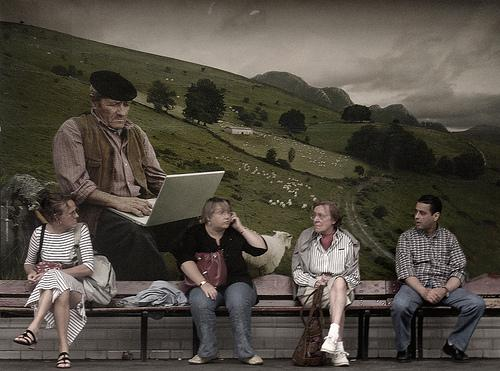Question: where are the people sitting?
Choices:
A. On the beach.
B. On the rocks.
C. On a bench.
D. On the curb.
Answer with the letter. Answer: C Question: who is on the bench?
Choices:
A. Four people.
B. One person.
C. No one.
D. Two girls.
Answer with the letter. Answer: A Question: what is on the mural?
Choices:
A. A football player.
B. A soldier.
C. A man with a computer.
D. An airman.
Answer with the letter. Answer: C Question: what does the woman have by her ear?
Choices:
A. An earring.
B. A hat.
C. Headphones.
D. A phone.
Answer with the letter. Answer: D Question: why does the woman have a phone?
Choices:
A. To text her husband.
B. To answer in case her daughter calls.
C. To make a phone call.
D. To listen to her voicemails.
Answer with the letter. Answer: C Question: how many people are on a phone?
Choices:
A. Two.
B. One.
C. Three.
D. Four.
Answer with the letter. Answer: B 